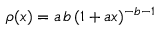<formula> <loc_0><loc_0><loc_500><loc_500>\rho ( x ) = a \, b \, ( 1 + a x ) ^ { - b - 1 }</formula> 